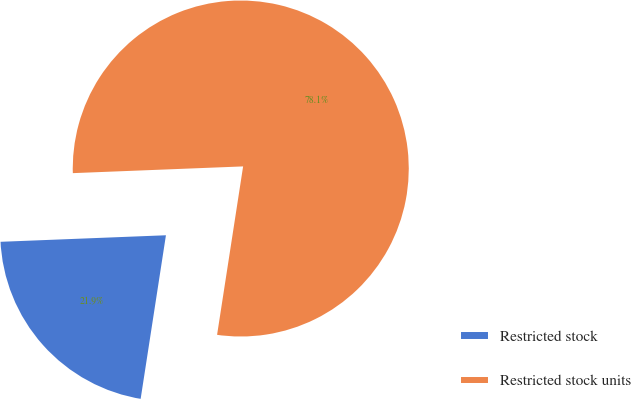Convert chart to OTSL. <chart><loc_0><loc_0><loc_500><loc_500><pie_chart><fcel>Restricted stock<fcel>Restricted stock units<nl><fcel>21.93%<fcel>78.07%<nl></chart> 